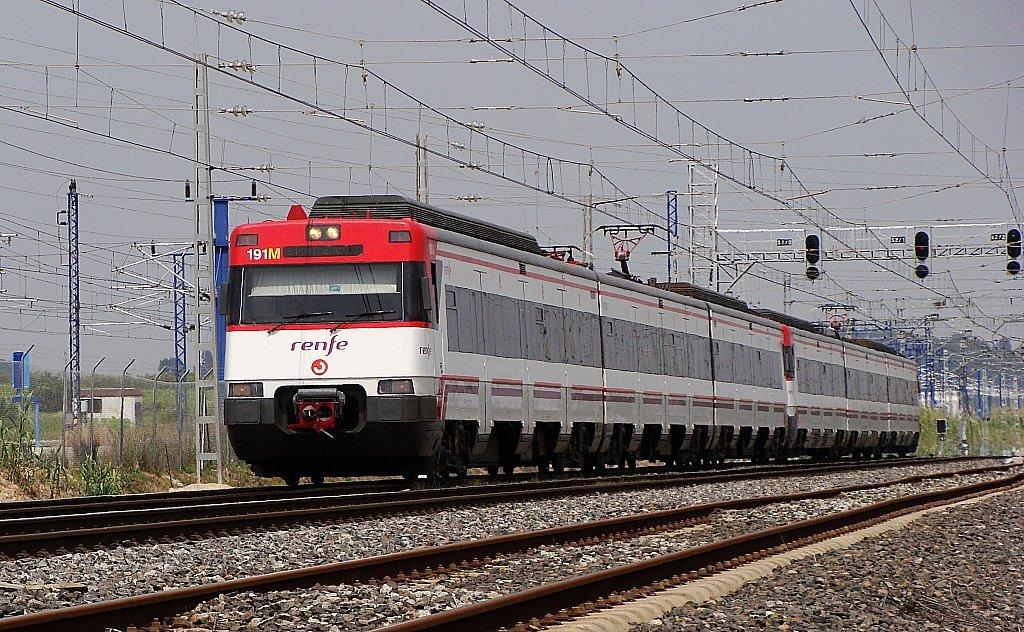What can be seen running parallel to each other in the image? There are two railway tracks in the image. What is present on one of the tracks? There is a train on one of the tracks. What else can be seen in the image besides the railway tracks and the train? There are cables visible in the image. What is visible at the top of the image? The sky is visible at the top of the image. How many different types of produce can be seen in the image? There is no produce present in the image; it features railway tracks, a train, cables, and the sky. Can you tell me how many times the train jumps over the cables in the image? The train does not jump over the cables in the image; it is stationary on one of the tracks. 